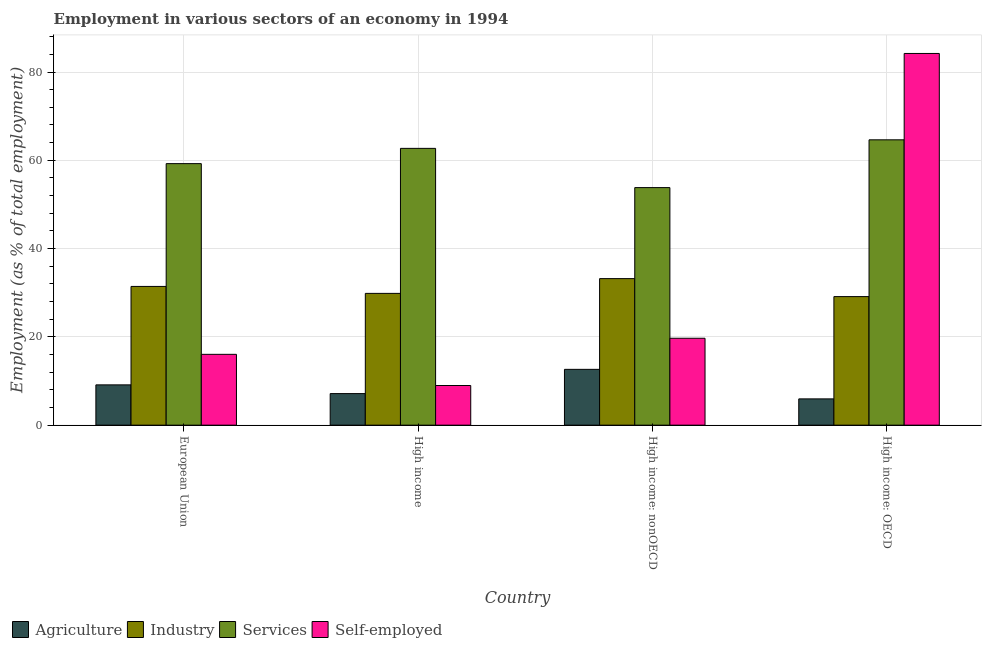How many different coloured bars are there?
Provide a succinct answer. 4. Are the number of bars per tick equal to the number of legend labels?
Your answer should be very brief. Yes. Are the number of bars on each tick of the X-axis equal?
Provide a short and direct response. Yes. How many bars are there on the 2nd tick from the right?
Give a very brief answer. 4. In how many cases, is the number of bars for a given country not equal to the number of legend labels?
Offer a terse response. 0. What is the percentage of workers in agriculture in High income?
Provide a short and direct response. 7.15. Across all countries, what is the maximum percentage of self employed workers?
Your answer should be compact. 84.21. Across all countries, what is the minimum percentage of workers in agriculture?
Make the answer very short. 5.95. In which country was the percentage of workers in agriculture maximum?
Give a very brief answer. High income: nonOECD. What is the total percentage of workers in services in the graph?
Ensure brevity in your answer.  240.41. What is the difference between the percentage of self employed workers in High income and that in High income: OECD?
Provide a short and direct response. -75.22. What is the difference between the percentage of workers in agriculture in High income: nonOECD and the percentage of self employed workers in High income?
Provide a succinct answer. 3.66. What is the average percentage of workers in agriculture per country?
Provide a short and direct response. 8.72. What is the difference between the percentage of workers in agriculture and percentage of workers in services in High income: OECD?
Keep it short and to the point. -58.69. What is the ratio of the percentage of workers in services in High income to that in High income: nonOECD?
Provide a short and direct response. 1.17. Is the percentage of workers in agriculture in European Union less than that in High income: nonOECD?
Your answer should be very brief. Yes. What is the difference between the highest and the second highest percentage of workers in industry?
Your response must be concise. 1.77. What is the difference between the highest and the lowest percentage of workers in services?
Ensure brevity in your answer.  10.82. Is the sum of the percentage of workers in industry in European Union and High income: OECD greater than the maximum percentage of self employed workers across all countries?
Keep it short and to the point. No. What does the 3rd bar from the left in High income represents?
Give a very brief answer. Services. What does the 4th bar from the right in High income: OECD represents?
Offer a terse response. Agriculture. How many bars are there?
Offer a very short reply. 16. How many countries are there in the graph?
Your answer should be compact. 4. What is the difference between two consecutive major ticks on the Y-axis?
Your answer should be compact. 20. Are the values on the major ticks of Y-axis written in scientific E-notation?
Offer a very short reply. No. What is the title of the graph?
Provide a succinct answer. Employment in various sectors of an economy in 1994. Does "Norway" appear as one of the legend labels in the graph?
Provide a succinct answer. No. What is the label or title of the Y-axis?
Offer a terse response. Employment (as % of total employment). What is the Employment (as % of total employment) in Agriculture in European Union?
Ensure brevity in your answer.  9.13. What is the Employment (as % of total employment) of Industry in European Union?
Offer a terse response. 31.43. What is the Employment (as % of total employment) in Services in European Union?
Provide a short and direct response. 59.25. What is the Employment (as % of total employment) in Self-employed in European Union?
Keep it short and to the point. 16.05. What is the Employment (as % of total employment) of Agriculture in High income?
Keep it short and to the point. 7.15. What is the Employment (as % of total employment) of Industry in High income?
Ensure brevity in your answer.  29.85. What is the Employment (as % of total employment) in Services in High income?
Ensure brevity in your answer.  62.71. What is the Employment (as % of total employment) in Self-employed in High income?
Your answer should be very brief. 8.98. What is the Employment (as % of total employment) in Agriculture in High income: nonOECD?
Make the answer very short. 12.64. What is the Employment (as % of total employment) in Industry in High income: nonOECD?
Provide a succinct answer. 33.2. What is the Employment (as % of total employment) of Services in High income: nonOECD?
Provide a short and direct response. 53.82. What is the Employment (as % of total employment) in Self-employed in High income: nonOECD?
Your answer should be compact. 19.69. What is the Employment (as % of total employment) of Agriculture in High income: OECD?
Provide a short and direct response. 5.95. What is the Employment (as % of total employment) of Industry in High income: OECD?
Ensure brevity in your answer.  29.12. What is the Employment (as % of total employment) in Services in High income: OECD?
Your answer should be compact. 64.64. What is the Employment (as % of total employment) of Self-employed in High income: OECD?
Offer a terse response. 84.21. Across all countries, what is the maximum Employment (as % of total employment) of Agriculture?
Offer a terse response. 12.64. Across all countries, what is the maximum Employment (as % of total employment) of Industry?
Ensure brevity in your answer.  33.2. Across all countries, what is the maximum Employment (as % of total employment) in Services?
Offer a terse response. 64.64. Across all countries, what is the maximum Employment (as % of total employment) in Self-employed?
Make the answer very short. 84.21. Across all countries, what is the minimum Employment (as % of total employment) of Agriculture?
Your answer should be compact. 5.95. Across all countries, what is the minimum Employment (as % of total employment) of Industry?
Your answer should be very brief. 29.12. Across all countries, what is the minimum Employment (as % of total employment) of Services?
Offer a very short reply. 53.82. Across all countries, what is the minimum Employment (as % of total employment) of Self-employed?
Ensure brevity in your answer.  8.98. What is the total Employment (as % of total employment) of Agriculture in the graph?
Offer a very short reply. 34.88. What is the total Employment (as % of total employment) of Industry in the graph?
Your response must be concise. 123.6. What is the total Employment (as % of total employment) in Services in the graph?
Provide a succinct answer. 240.41. What is the total Employment (as % of total employment) in Self-employed in the graph?
Make the answer very short. 128.92. What is the difference between the Employment (as % of total employment) in Agriculture in European Union and that in High income?
Provide a short and direct response. 1.98. What is the difference between the Employment (as % of total employment) of Industry in European Union and that in High income?
Your answer should be compact. 1.57. What is the difference between the Employment (as % of total employment) in Services in European Union and that in High income?
Give a very brief answer. -3.46. What is the difference between the Employment (as % of total employment) in Self-employed in European Union and that in High income?
Provide a succinct answer. 7.06. What is the difference between the Employment (as % of total employment) of Agriculture in European Union and that in High income: nonOECD?
Provide a succinct answer. -3.52. What is the difference between the Employment (as % of total employment) in Industry in European Union and that in High income: nonOECD?
Provide a short and direct response. -1.77. What is the difference between the Employment (as % of total employment) in Services in European Union and that in High income: nonOECD?
Provide a succinct answer. 5.43. What is the difference between the Employment (as % of total employment) of Self-employed in European Union and that in High income: nonOECD?
Give a very brief answer. -3.64. What is the difference between the Employment (as % of total employment) in Agriculture in European Union and that in High income: OECD?
Your response must be concise. 3.17. What is the difference between the Employment (as % of total employment) in Industry in European Union and that in High income: OECD?
Your answer should be very brief. 2.3. What is the difference between the Employment (as % of total employment) in Services in European Union and that in High income: OECD?
Your answer should be compact. -5.39. What is the difference between the Employment (as % of total employment) in Self-employed in European Union and that in High income: OECD?
Provide a short and direct response. -68.16. What is the difference between the Employment (as % of total employment) of Agriculture in High income and that in High income: nonOECD?
Your answer should be very brief. -5.49. What is the difference between the Employment (as % of total employment) of Industry in High income and that in High income: nonOECD?
Provide a succinct answer. -3.35. What is the difference between the Employment (as % of total employment) of Services in High income and that in High income: nonOECD?
Give a very brief answer. 8.89. What is the difference between the Employment (as % of total employment) of Self-employed in High income and that in High income: nonOECD?
Make the answer very short. -10.71. What is the difference between the Employment (as % of total employment) of Agriculture in High income and that in High income: OECD?
Give a very brief answer. 1.2. What is the difference between the Employment (as % of total employment) in Industry in High income and that in High income: OECD?
Provide a short and direct response. 0.73. What is the difference between the Employment (as % of total employment) of Services in High income and that in High income: OECD?
Provide a short and direct response. -1.94. What is the difference between the Employment (as % of total employment) of Self-employed in High income and that in High income: OECD?
Your response must be concise. -75.22. What is the difference between the Employment (as % of total employment) of Agriculture in High income: nonOECD and that in High income: OECD?
Provide a short and direct response. 6.69. What is the difference between the Employment (as % of total employment) in Industry in High income: nonOECD and that in High income: OECD?
Give a very brief answer. 4.07. What is the difference between the Employment (as % of total employment) in Services in High income: nonOECD and that in High income: OECD?
Provide a short and direct response. -10.82. What is the difference between the Employment (as % of total employment) in Self-employed in High income: nonOECD and that in High income: OECD?
Ensure brevity in your answer.  -64.52. What is the difference between the Employment (as % of total employment) of Agriculture in European Union and the Employment (as % of total employment) of Industry in High income?
Give a very brief answer. -20.73. What is the difference between the Employment (as % of total employment) of Agriculture in European Union and the Employment (as % of total employment) of Services in High income?
Provide a succinct answer. -53.58. What is the difference between the Employment (as % of total employment) of Agriculture in European Union and the Employment (as % of total employment) of Self-employed in High income?
Make the answer very short. 0.15. What is the difference between the Employment (as % of total employment) in Industry in European Union and the Employment (as % of total employment) in Services in High income?
Your answer should be compact. -31.28. What is the difference between the Employment (as % of total employment) of Industry in European Union and the Employment (as % of total employment) of Self-employed in High income?
Ensure brevity in your answer.  22.45. What is the difference between the Employment (as % of total employment) of Services in European Union and the Employment (as % of total employment) of Self-employed in High income?
Give a very brief answer. 50.27. What is the difference between the Employment (as % of total employment) in Agriculture in European Union and the Employment (as % of total employment) in Industry in High income: nonOECD?
Your response must be concise. -24.07. What is the difference between the Employment (as % of total employment) of Agriculture in European Union and the Employment (as % of total employment) of Services in High income: nonOECD?
Your answer should be compact. -44.69. What is the difference between the Employment (as % of total employment) in Agriculture in European Union and the Employment (as % of total employment) in Self-employed in High income: nonOECD?
Your answer should be very brief. -10.56. What is the difference between the Employment (as % of total employment) of Industry in European Union and the Employment (as % of total employment) of Services in High income: nonOECD?
Your response must be concise. -22.39. What is the difference between the Employment (as % of total employment) in Industry in European Union and the Employment (as % of total employment) in Self-employed in High income: nonOECD?
Offer a very short reply. 11.74. What is the difference between the Employment (as % of total employment) in Services in European Union and the Employment (as % of total employment) in Self-employed in High income: nonOECD?
Your answer should be compact. 39.56. What is the difference between the Employment (as % of total employment) in Agriculture in European Union and the Employment (as % of total employment) in Industry in High income: OECD?
Provide a succinct answer. -20. What is the difference between the Employment (as % of total employment) in Agriculture in European Union and the Employment (as % of total employment) in Services in High income: OECD?
Offer a terse response. -55.51. What is the difference between the Employment (as % of total employment) in Agriculture in European Union and the Employment (as % of total employment) in Self-employed in High income: OECD?
Keep it short and to the point. -75.08. What is the difference between the Employment (as % of total employment) of Industry in European Union and the Employment (as % of total employment) of Services in High income: OECD?
Make the answer very short. -33.21. What is the difference between the Employment (as % of total employment) of Industry in European Union and the Employment (as % of total employment) of Self-employed in High income: OECD?
Ensure brevity in your answer.  -52.78. What is the difference between the Employment (as % of total employment) in Services in European Union and the Employment (as % of total employment) in Self-employed in High income: OECD?
Make the answer very short. -24.96. What is the difference between the Employment (as % of total employment) of Agriculture in High income and the Employment (as % of total employment) of Industry in High income: nonOECD?
Your response must be concise. -26.05. What is the difference between the Employment (as % of total employment) of Agriculture in High income and the Employment (as % of total employment) of Services in High income: nonOECD?
Keep it short and to the point. -46.67. What is the difference between the Employment (as % of total employment) of Agriculture in High income and the Employment (as % of total employment) of Self-employed in High income: nonOECD?
Keep it short and to the point. -12.54. What is the difference between the Employment (as % of total employment) of Industry in High income and the Employment (as % of total employment) of Services in High income: nonOECD?
Keep it short and to the point. -23.96. What is the difference between the Employment (as % of total employment) of Industry in High income and the Employment (as % of total employment) of Self-employed in High income: nonOECD?
Offer a terse response. 10.17. What is the difference between the Employment (as % of total employment) of Services in High income and the Employment (as % of total employment) of Self-employed in High income: nonOECD?
Offer a terse response. 43.02. What is the difference between the Employment (as % of total employment) of Agriculture in High income and the Employment (as % of total employment) of Industry in High income: OECD?
Make the answer very short. -21.97. What is the difference between the Employment (as % of total employment) in Agriculture in High income and the Employment (as % of total employment) in Services in High income: OECD?
Ensure brevity in your answer.  -57.49. What is the difference between the Employment (as % of total employment) of Agriculture in High income and the Employment (as % of total employment) of Self-employed in High income: OECD?
Offer a terse response. -77.06. What is the difference between the Employment (as % of total employment) of Industry in High income and the Employment (as % of total employment) of Services in High income: OECD?
Keep it short and to the point. -34.79. What is the difference between the Employment (as % of total employment) in Industry in High income and the Employment (as % of total employment) in Self-employed in High income: OECD?
Provide a short and direct response. -54.35. What is the difference between the Employment (as % of total employment) of Services in High income and the Employment (as % of total employment) of Self-employed in High income: OECD?
Provide a short and direct response. -21.5. What is the difference between the Employment (as % of total employment) of Agriculture in High income: nonOECD and the Employment (as % of total employment) of Industry in High income: OECD?
Keep it short and to the point. -16.48. What is the difference between the Employment (as % of total employment) in Agriculture in High income: nonOECD and the Employment (as % of total employment) in Services in High income: OECD?
Offer a very short reply. -52. What is the difference between the Employment (as % of total employment) of Agriculture in High income: nonOECD and the Employment (as % of total employment) of Self-employed in High income: OECD?
Your answer should be very brief. -71.56. What is the difference between the Employment (as % of total employment) in Industry in High income: nonOECD and the Employment (as % of total employment) in Services in High income: OECD?
Your response must be concise. -31.44. What is the difference between the Employment (as % of total employment) of Industry in High income: nonOECD and the Employment (as % of total employment) of Self-employed in High income: OECD?
Provide a short and direct response. -51.01. What is the difference between the Employment (as % of total employment) of Services in High income: nonOECD and the Employment (as % of total employment) of Self-employed in High income: OECD?
Provide a short and direct response. -30.39. What is the average Employment (as % of total employment) in Agriculture per country?
Your answer should be very brief. 8.72. What is the average Employment (as % of total employment) of Industry per country?
Offer a very short reply. 30.9. What is the average Employment (as % of total employment) in Services per country?
Keep it short and to the point. 60.1. What is the average Employment (as % of total employment) in Self-employed per country?
Provide a short and direct response. 32.23. What is the difference between the Employment (as % of total employment) in Agriculture and Employment (as % of total employment) in Industry in European Union?
Give a very brief answer. -22.3. What is the difference between the Employment (as % of total employment) in Agriculture and Employment (as % of total employment) in Services in European Union?
Ensure brevity in your answer.  -50.12. What is the difference between the Employment (as % of total employment) of Agriculture and Employment (as % of total employment) of Self-employed in European Union?
Provide a short and direct response. -6.92. What is the difference between the Employment (as % of total employment) in Industry and Employment (as % of total employment) in Services in European Union?
Your answer should be compact. -27.82. What is the difference between the Employment (as % of total employment) in Industry and Employment (as % of total employment) in Self-employed in European Union?
Offer a terse response. 15.38. What is the difference between the Employment (as % of total employment) in Services and Employment (as % of total employment) in Self-employed in European Union?
Make the answer very short. 43.2. What is the difference between the Employment (as % of total employment) in Agriculture and Employment (as % of total employment) in Industry in High income?
Offer a very short reply. -22.7. What is the difference between the Employment (as % of total employment) in Agriculture and Employment (as % of total employment) in Services in High income?
Give a very brief answer. -55.55. What is the difference between the Employment (as % of total employment) of Agriculture and Employment (as % of total employment) of Self-employed in High income?
Keep it short and to the point. -1.83. What is the difference between the Employment (as % of total employment) of Industry and Employment (as % of total employment) of Services in High income?
Offer a very short reply. -32.85. What is the difference between the Employment (as % of total employment) in Industry and Employment (as % of total employment) in Self-employed in High income?
Your answer should be compact. 20.87. What is the difference between the Employment (as % of total employment) of Services and Employment (as % of total employment) of Self-employed in High income?
Your answer should be very brief. 53.72. What is the difference between the Employment (as % of total employment) in Agriculture and Employment (as % of total employment) in Industry in High income: nonOECD?
Your response must be concise. -20.55. What is the difference between the Employment (as % of total employment) of Agriculture and Employment (as % of total employment) of Services in High income: nonOECD?
Keep it short and to the point. -41.17. What is the difference between the Employment (as % of total employment) in Agriculture and Employment (as % of total employment) in Self-employed in High income: nonOECD?
Keep it short and to the point. -7.04. What is the difference between the Employment (as % of total employment) in Industry and Employment (as % of total employment) in Services in High income: nonOECD?
Offer a terse response. -20.62. What is the difference between the Employment (as % of total employment) of Industry and Employment (as % of total employment) of Self-employed in High income: nonOECD?
Provide a short and direct response. 13.51. What is the difference between the Employment (as % of total employment) in Services and Employment (as % of total employment) in Self-employed in High income: nonOECD?
Keep it short and to the point. 34.13. What is the difference between the Employment (as % of total employment) of Agriculture and Employment (as % of total employment) of Industry in High income: OECD?
Give a very brief answer. -23.17. What is the difference between the Employment (as % of total employment) in Agriculture and Employment (as % of total employment) in Services in High income: OECD?
Offer a very short reply. -58.69. What is the difference between the Employment (as % of total employment) of Agriculture and Employment (as % of total employment) of Self-employed in High income: OECD?
Ensure brevity in your answer.  -78.25. What is the difference between the Employment (as % of total employment) of Industry and Employment (as % of total employment) of Services in High income: OECD?
Offer a terse response. -35.52. What is the difference between the Employment (as % of total employment) of Industry and Employment (as % of total employment) of Self-employed in High income: OECD?
Keep it short and to the point. -55.08. What is the difference between the Employment (as % of total employment) of Services and Employment (as % of total employment) of Self-employed in High income: OECD?
Provide a succinct answer. -19.57. What is the ratio of the Employment (as % of total employment) in Agriculture in European Union to that in High income?
Your response must be concise. 1.28. What is the ratio of the Employment (as % of total employment) of Industry in European Union to that in High income?
Your answer should be very brief. 1.05. What is the ratio of the Employment (as % of total employment) in Services in European Union to that in High income?
Ensure brevity in your answer.  0.94. What is the ratio of the Employment (as % of total employment) in Self-employed in European Union to that in High income?
Provide a succinct answer. 1.79. What is the ratio of the Employment (as % of total employment) of Agriculture in European Union to that in High income: nonOECD?
Keep it short and to the point. 0.72. What is the ratio of the Employment (as % of total employment) of Industry in European Union to that in High income: nonOECD?
Provide a short and direct response. 0.95. What is the ratio of the Employment (as % of total employment) of Services in European Union to that in High income: nonOECD?
Your answer should be compact. 1.1. What is the ratio of the Employment (as % of total employment) of Self-employed in European Union to that in High income: nonOECD?
Provide a short and direct response. 0.81. What is the ratio of the Employment (as % of total employment) in Agriculture in European Union to that in High income: OECD?
Provide a succinct answer. 1.53. What is the ratio of the Employment (as % of total employment) in Industry in European Union to that in High income: OECD?
Offer a very short reply. 1.08. What is the ratio of the Employment (as % of total employment) in Services in European Union to that in High income: OECD?
Offer a very short reply. 0.92. What is the ratio of the Employment (as % of total employment) in Self-employed in European Union to that in High income: OECD?
Keep it short and to the point. 0.19. What is the ratio of the Employment (as % of total employment) of Agriculture in High income to that in High income: nonOECD?
Provide a succinct answer. 0.57. What is the ratio of the Employment (as % of total employment) of Industry in High income to that in High income: nonOECD?
Offer a very short reply. 0.9. What is the ratio of the Employment (as % of total employment) of Services in High income to that in High income: nonOECD?
Keep it short and to the point. 1.17. What is the ratio of the Employment (as % of total employment) in Self-employed in High income to that in High income: nonOECD?
Make the answer very short. 0.46. What is the ratio of the Employment (as % of total employment) in Agriculture in High income to that in High income: OECD?
Make the answer very short. 1.2. What is the ratio of the Employment (as % of total employment) in Industry in High income to that in High income: OECD?
Your response must be concise. 1.02. What is the ratio of the Employment (as % of total employment) of Services in High income to that in High income: OECD?
Keep it short and to the point. 0.97. What is the ratio of the Employment (as % of total employment) of Self-employed in High income to that in High income: OECD?
Offer a very short reply. 0.11. What is the ratio of the Employment (as % of total employment) of Agriculture in High income: nonOECD to that in High income: OECD?
Offer a terse response. 2.12. What is the ratio of the Employment (as % of total employment) in Industry in High income: nonOECD to that in High income: OECD?
Provide a succinct answer. 1.14. What is the ratio of the Employment (as % of total employment) of Services in High income: nonOECD to that in High income: OECD?
Provide a short and direct response. 0.83. What is the ratio of the Employment (as % of total employment) in Self-employed in High income: nonOECD to that in High income: OECD?
Provide a short and direct response. 0.23. What is the difference between the highest and the second highest Employment (as % of total employment) of Agriculture?
Provide a succinct answer. 3.52. What is the difference between the highest and the second highest Employment (as % of total employment) of Industry?
Ensure brevity in your answer.  1.77. What is the difference between the highest and the second highest Employment (as % of total employment) of Services?
Provide a succinct answer. 1.94. What is the difference between the highest and the second highest Employment (as % of total employment) in Self-employed?
Your answer should be compact. 64.52. What is the difference between the highest and the lowest Employment (as % of total employment) in Agriculture?
Offer a very short reply. 6.69. What is the difference between the highest and the lowest Employment (as % of total employment) in Industry?
Your response must be concise. 4.07. What is the difference between the highest and the lowest Employment (as % of total employment) in Services?
Your answer should be compact. 10.82. What is the difference between the highest and the lowest Employment (as % of total employment) in Self-employed?
Offer a terse response. 75.22. 